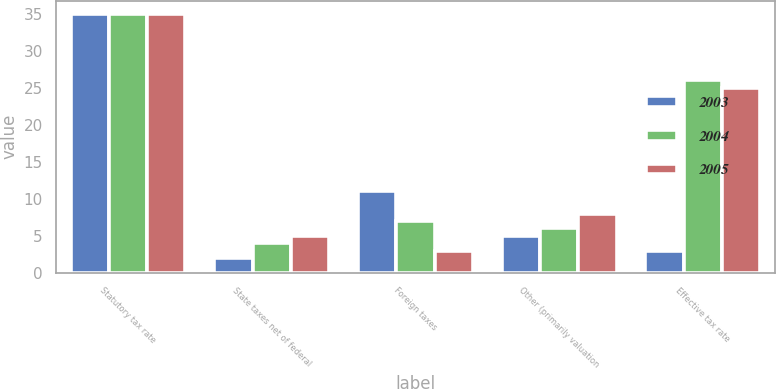<chart> <loc_0><loc_0><loc_500><loc_500><stacked_bar_chart><ecel><fcel>Statutory tax rate<fcel>State taxes net of federal<fcel>Foreign taxes<fcel>Other (primarily valuation<fcel>Effective tax rate<nl><fcel>2003<fcel>35<fcel>2<fcel>11<fcel>5<fcel>3<nl><fcel>2004<fcel>35<fcel>4<fcel>7<fcel>6<fcel>26<nl><fcel>2005<fcel>35<fcel>5<fcel>3<fcel>8<fcel>25<nl></chart> 